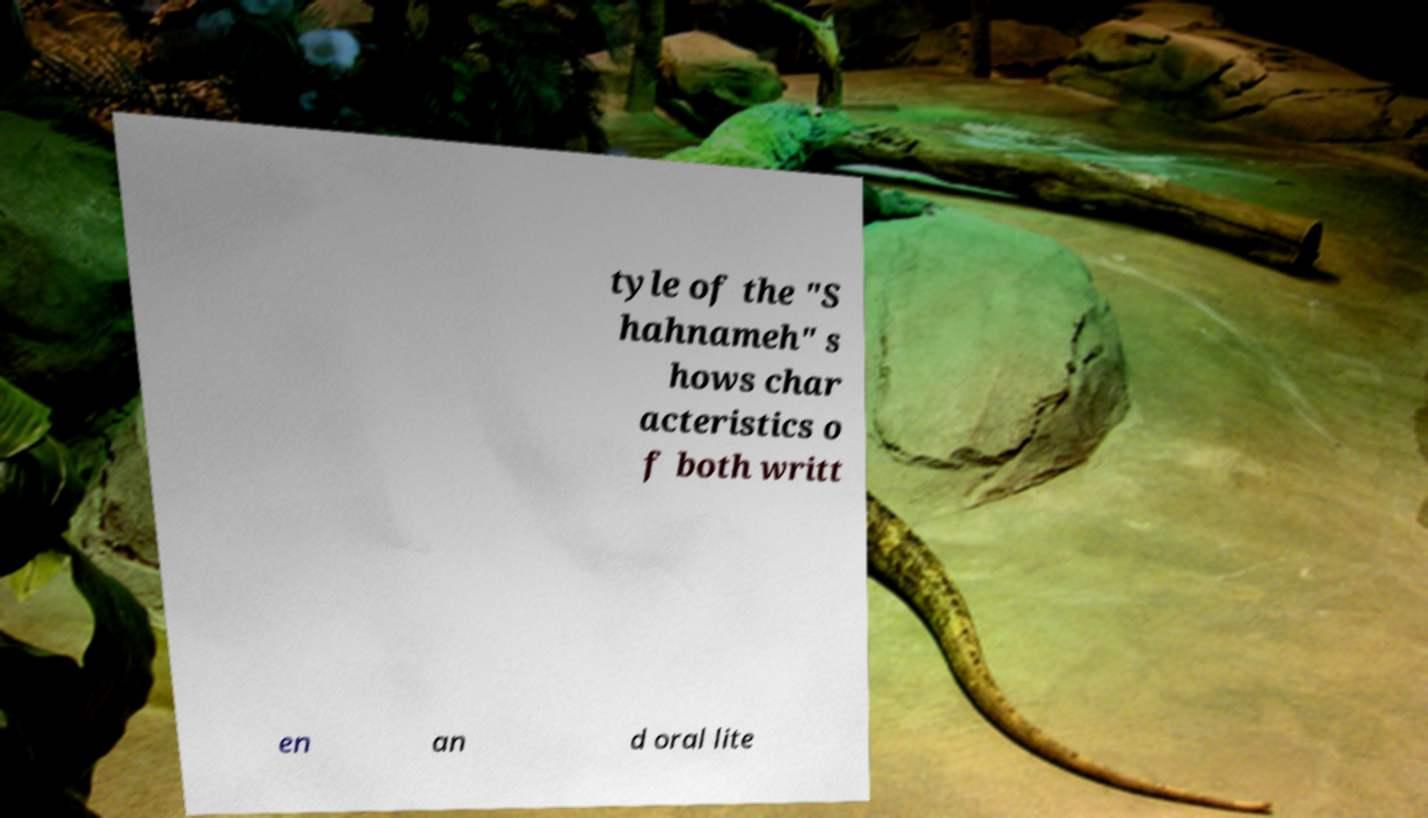What messages or text are displayed in this image? I need them in a readable, typed format. tyle of the "S hahnameh" s hows char acteristics o f both writt en an d oral lite 